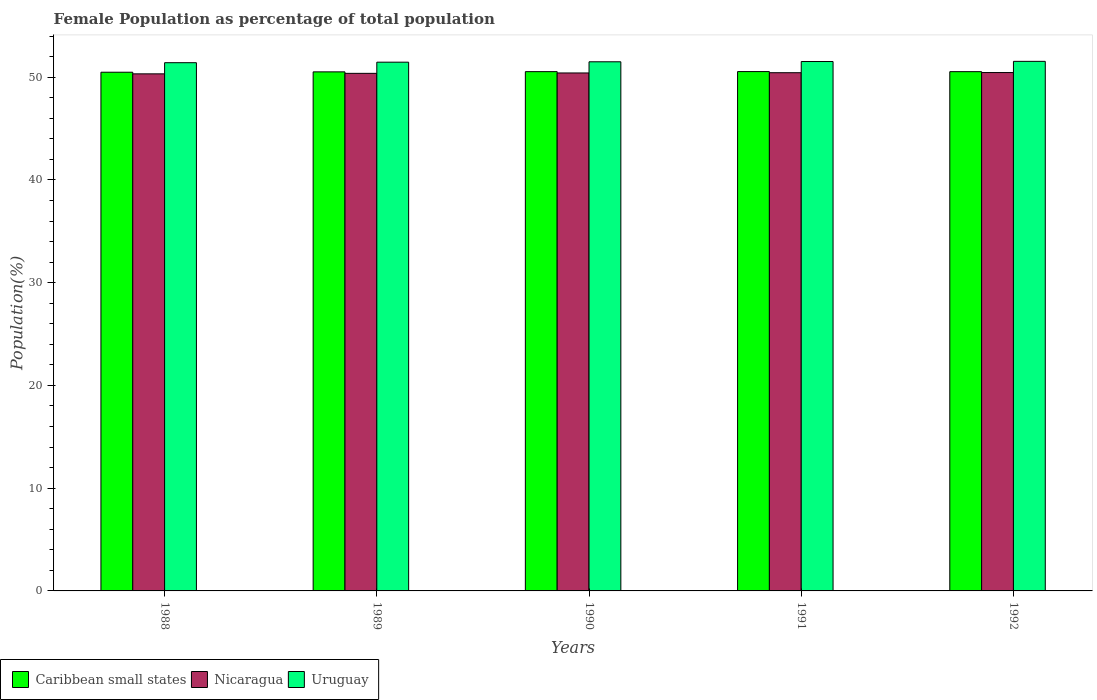How many groups of bars are there?
Your answer should be very brief. 5. Are the number of bars per tick equal to the number of legend labels?
Give a very brief answer. Yes. What is the label of the 1st group of bars from the left?
Your response must be concise. 1988. In how many cases, is the number of bars for a given year not equal to the number of legend labels?
Provide a succinct answer. 0. What is the female population in in Uruguay in 1992?
Give a very brief answer. 51.54. Across all years, what is the maximum female population in in Caribbean small states?
Offer a very short reply. 50.54. Across all years, what is the minimum female population in in Uruguay?
Offer a terse response. 51.41. In which year was the female population in in Caribbean small states minimum?
Your answer should be compact. 1988. What is the total female population in in Uruguay in the graph?
Offer a very short reply. 257.42. What is the difference between the female population in in Nicaragua in 1989 and that in 1992?
Provide a succinct answer. -0.08. What is the difference between the female population in in Nicaragua in 1992 and the female population in in Uruguay in 1988?
Your answer should be compact. -0.96. What is the average female population in in Caribbean small states per year?
Your response must be concise. 50.52. In the year 1989, what is the difference between the female population in in Caribbean small states and female population in in Uruguay?
Your answer should be very brief. -0.94. What is the ratio of the female population in in Uruguay in 1991 to that in 1992?
Keep it short and to the point. 1. Is the difference between the female population in in Caribbean small states in 1990 and 1991 greater than the difference between the female population in in Uruguay in 1990 and 1991?
Provide a succinct answer. Yes. What is the difference between the highest and the second highest female population in in Uruguay?
Offer a terse response. 0.02. What is the difference between the highest and the lowest female population in in Nicaragua?
Make the answer very short. 0.13. In how many years, is the female population in in Caribbean small states greater than the average female population in in Caribbean small states taken over all years?
Offer a terse response. 3. Is the sum of the female population in in Uruguay in 1988 and 1990 greater than the maximum female population in in Nicaragua across all years?
Offer a terse response. Yes. What does the 3rd bar from the left in 1988 represents?
Offer a terse response. Uruguay. What does the 3rd bar from the right in 1988 represents?
Provide a succinct answer. Caribbean small states. Are all the bars in the graph horizontal?
Keep it short and to the point. No. How many years are there in the graph?
Make the answer very short. 5. What is the difference between two consecutive major ticks on the Y-axis?
Provide a succinct answer. 10. Are the values on the major ticks of Y-axis written in scientific E-notation?
Your answer should be compact. No. Does the graph contain any zero values?
Your answer should be very brief. No. Where does the legend appear in the graph?
Your answer should be very brief. Bottom left. How are the legend labels stacked?
Provide a short and direct response. Horizontal. What is the title of the graph?
Ensure brevity in your answer.  Female Population as percentage of total population. Does "South Asia" appear as one of the legend labels in the graph?
Your answer should be very brief. No. What is the label or title of the X-axis?
Offer a terse response. Years. What is the label or title of the Y-axis?
Make the answer very short. Population(%). What is the Population(%) of Caribbean small states in 1988?
Give a very brief answer. 50.48. What is the Population(%) of Nicaragua in 1988?
Your answer should be compact. 50.32. What is the Population(%) in Uruguay in 1988?
Provide a succinct answer. 51.41. What is the Population(%) in Caribbean small states in 1989?
Your response must be concise. 50.51. What is the Population(%) of Nicaragua in 1989?
Provide a short and direct response. 50.37. What is the Population(%) in Uruguay in 1989?
Provide a short and direct response. 51.46. What is the Population(%) in Caribbean small states in 1990?
Provide a short and direct response. 50.54. What is the Population(%) in Nicaragua in 1990?
Provide a short and direct response. 50.41. What is the Population(%) in Uruguay in 1990?
Provide a short and direct response. 51.5. What is the Population(%) of Caribbean small states in 1991?
Provide a succinct answer. 50.54. What is the Population(%) in Nicaragua in 1991?
Make the answer very short. 50.43. What is the Population(%) of Uruguay in 1991?
Make the answer very short. 51.52. What is the Population(%) of Caribbean small states in 1992?
Provide a succinct answer. 50.53. What is the Population(%) in Nicaragua in 1992?
Make the answer very short. 50.45. What is the Population(%) in Uruguay in 1992?
Your response must be concise. 51.54. Across all years, what is the maximum Population(%) in Caribbean small states?
Offer a very short reply. 50.54. Across all years, what is the maximum Population(%) of Nicaragua?
Ensure brevity in your answer.  50.45. Across all years, what is the maximum Population(%) in Uruguay?
Make the answer very short. 51.54. Across all years, what is the minimum Population(%) in Caribbean small states?
Offer a very short reply. 50.48. Across all years, what is the minimum Population(%) of Nicaragua?
Your answer should be very brief. 50.32. Across all years, what is the minimum Population(%) of Uruguay?
Offer a terse response. 51.41. What is the total Population(%) in Caribbean small states in the graph?
Offer a terse response. 252.6. What is the total Population(%) of Nicaragua in the graph?
Provide a short and direct response. 251.98. What is the total Population(%) of Uruguay in the graph?
Ensure brevity in your answer.  257.42. What is the difference between the Population(%) in Caribbean small states in 1988 and that in 1989?
Give a very brief answer. -0.04. What is the difference between the Population(%) of Nicaragua in 1988 and that in 1989?
Your answer should be compact. -0.05. What is the difference between the Population(%) of Uruguay in 1988 and that in 1989?
Make the answer very short. -0.05. What is the difference between the Population(%) of Caribbean small states in 1988 and that in 1990?
Provide a succinct answer. -0.06. What is the difference between the Population(%) of Nicaragua in 1988 and that in 1990?
Make the answer very short. -0.09. What is the difference between the Population(%) in Uruguay in 1988 and that in 1990?
Your answer should be compact. -0.09. What is the difference between the Population(%) in Caribbean small states in 1988 and that in 1991?
Keep it short and to the point. -0.06. What is the difference between the Population(%) in Nicaragua in 1988 and that in 1991?
Ensure brevity in your answer.  -0.11. What is the difference between the Population(%) of Uruguay in 1988 and that in 1991?
Offer a terse response. -0.11. What is the difference between the Population(%) of Caribbean small states in 1988 and that in 1992?
Give a very brief answer. -0.05. What is the difference between the Population(%) of Nicaragua in 1988 and that in 1992?
Make the answer very short. -0.13. What is the difference between the Population(%) of Uruguay in 1988 and that in 1992?
Keep it short and to the point. -0.13. What is the difference between the Population(%) in Caribbean small states in 1989 and that in 1990?
Offer a very short reply. -0.02. What is the difference between the Population(%) in Nicaragua in 1989 and that in 1990?
Offer a terse response. -0.04. What is the difference between the Population(%) in Uruguay in 1989 and that in 1990?
Your answer should be compact. -0.04. What is the difference between the Population(%) of Caribbean small states in 1989 and that in 1991?
Make the answer very short. -0.03. What is the difference between the Population(%) of Nicaragua in 1989 and that in 1991?
Make the answer very short. -0.06. What is the difference between the Population(%) in Uruguay in 1989 and that in 1991?
Provide a short and direct response. -0.06. What is the difference between the Population(%) in Caribbean small states in 1989 and that in 1992?
Your response must be concise. -0.02. What is the difference between the Population(%) of Nicaragua in 1989 and that in 1992?
Provide a succinct answer. -0.08. What is the difference between the Population(%) in Uruguay in 1989 and that in 1992?
Your answer should be very brief. -0.08. What is the difference between the Population(%) in Caribbean small states in 1990 and that in 1991?
Provide a succinct answer. -0.01. What is the difference between the Population(%) of Nicaragua in 1990 and that in 1991?
Offer a very short reply. -0.03. What is the difference between the Population(%) of Uruguay in 1990 and that in 1991?
Make the answer very short. -0.03. What is the difference between the Population(%) of Caribbean small states in 1990 and that in 1992?
Your response must be concise. 0. What is the difference between the Population(%) in Nicaragua in 1990 and that in 1992?
Keep it short and to the point. -0.04. What is the difference between the Population(%) of Uruguay in 1990 and that in 1992?
Your response must be concise. -0.04. What is the difference between the Population(%) in Caribbean small states in 1991 and that in 1992?
Your response must be concise. 0.01. What is the difference between the Population(%) in Nicaragua in 1991 and that in 1992?
Your answer should be compact. -0.01. What is the difference between the Population(%) in Uruguay in 1991 and that in 1992?
Make the answer very short. -0.02. What is the difference between the Population(%) in Caribbean small states in 1988 and the Population(%) in Nicaragua in 1989?
Make the answer very short. 0.11. What is the difference between the Population(%) in Caribbean small states in 1988 and the Population(%) in Uruguay in 1989?
Provide a succinct answer. -0.98. What is the difference between the Population(%) of Nicaragua in 1988 and the Population(%) of Uruguay in 1989?
Ensure brevity in your answer.  -1.13. What is the difference between the Population(%) in Caribbean small states in 1988 and the Population(%) in Nicaragua in 1990?
Ensure brevity in your answer.  0.07. What is the difference between the Population(%) of Caribbean small states in 1988 and the Population(%) of Uruguay in 1990?
Offer a very short reply. -1.02. What is the difference between the Population(%) of Nicaragua in 1988 and the Population(%) of Uruguay in 1990?
Provide a short and direct response. -1.17. What is the difference between the Population(%) in Caribbean small states in 1988 and the Population(%) in Nicaragua in 1991?
Ensure brevity in your answer.  0.05. What is the difference between the Population(%) of Caribbean small states in 1988 and the Population(%) of Uruguay in 1991?
Your answer should be very brief. -1.04. What is the difference between the Population(%) of Nicaragua in 1988 and the Population(%) of Uruguay in 1991?
Your answer should be compact. -1.2. What is the difference between the Population(%) in Caribbean small states in 1988 and the Population(%) in Nicaragua in 1992?
Ensure brevity in your answer.  0.03. What is the difference between the Population(%) of Caribbean small states in 1988 and the Population(%) of Uruguay in 1992?
Keep it short and to the point. -1.06. What is the difference between the Population(%) of Nicaragua in 1988 and the Population(%) of Uruguay in 1992?
Your answer should be compact. -1.22. What is the difference between the Population(%) in Caribbean small states in 1989 and the Population(%) in Nicaragua in 1990?
Your answer should be very brief. 0.11. What is the difference between the Population(%) in Caribbean small states in 1989 and the Population(%) in Uruguay in 1990?
Your response must be concise. -0.98. What is the difference between the Population(%) in Nicaragua in 1989 and the Population(%) in Uruguay in 1990?
Offer a terse response. -1.12. What is the difference between the Population(%) in Caribbean small states in 1989 and the Population(%) in Nicaragua in 1991?
Give a very brief answer. 0.08. What is the difference between the Population(%) in Caribbean small states in 1989 and the Population(%) in Uruguay in 1991?
Your answer should be very brief. -1.01. What is the difference between the Population(%) of Nicaragua in 1989 and the Population(%) of Uruguay in 1991?
Provide a short and direct response. -1.15. What is the difference between the Population(%) in Caribbean small states in 1989 and the Population(%) in Nicaragua in 1992?
Ensure brevity in your answer.  0.07. What is the difference between the Population(%) of Caribbean small states in 1989 and the Population(%) of Uruguay in 1992?
Make the answer very short. -1.02. What is the difference between the Population(%) in Nicaragua in 1989 and the Population(%) in Uruguay in 1992?
Your response must be concise. -1.17. What is the difference between the Population(%) of Caribbean small states in 1990 and the Population(%) of Nicaragua in 1991?
Make the answer very short. 0.1. What is the difference between the Population(%) in Caribbean small states in 1990 and the Population(%) in Uruguay in 1991?
Your answer should be compact. -0.99. What is the difference between the Population(%) of Nicaragua in 1990 and the Population(%) of Uruguay in 1991?
Offer a very short reply. -1.11. What is the difference between the Population(%) of Caribbean small states in 1990 and the Population(%) of Nicaragua in 1992?
Your response must be concise. 0.09. What is the difference between the Population(%) in Caribbean small states in 1990 and the Population(%) in Uruguay in 1992?
Your answer should be very brief. -1. What is the difference between the Population(%) in Nicaragua in 1990 and the Population(%) in Uruguay in 1992?
Provide a succinct answer. -1.13. What is the difference between the Population(%) in Caribbean small states in 1991 and the Population(%) in Nicaragua in 1992?
Your answer should be compact. 0.09. What is the difference between the Population(%) of Caribbean small states in 1991 and the Population(%) of Uruguay in 1992?
Give a very brief answer. -1. What is the difference between the Population(%) in Nicaragua in 1991 and the Population(%) in Uruguay in 1992?
Make the answer very short. -1.1. What is the average Population(%) of Caribbean small states per year?
Make the answer very short. 50.52. What is the average Population(%) of Nicaragua per year?
Provide a short and direct response. 50.4. What is the average Population(%) of Uruguay per year?
Your answer should be compact. 51.48. In the year 1988, what is the difference between the Population(%) of Caribbean small states and Population(%) of Nicaragua?
Offer a very short reply. 0.16. In the year 1988, what is the difference between the Population(%) of Caribbean small states and Population(%) of Uruguay?
Offer a terse response. -0.93. In the year 1988, what is the difference between the Population(%) of Nicaragua and Population(%) of Uruguay?
Offer a terse response. -1.08. In the year 1989, what is the difference between the Population(%) in Caribbean small states and Population(%) in Nicaragua?
Your response must be concise. 0.14. In the year 1989, what is the difference between the Population(%) in Caribbean small states and Population(%) in Uruguay?
Your answer should be very brief. -0.94. In the year 1989, what is the difference between the Population(%) in Nicaragua and Population(%) in Uruguay?
Offer a terse response. -1.09. In the year 1990, what is the difference between the Population(%) of Caribbean small states and Population(%) of Nicaragua?
Make the answer very short. 0.13. In the year 1990, what is the difference between the Population(%) in Caribbean small states and Population(%) in Uruguay?
Provide a short and direct response. -0.96. In the year 1990, what is the difference between the Population(%) in Nicaragua and Population(%) in Uruguay?
Your answer should be compact. -1.09. In the year 1991, what is the difference between the Population(%) in Caribbean small states and Population(%) in Nicaragua?
Offer a very short reply. 0.11. In the year 1991, what is the difference between the Population(%) in Caribbean small states and Population(%) in Uruguay?
Keep it short and to the point. -0.98. In the year 1991, what is the difference between the Population(%) of Nicaragua and Population(%) of Uruguay?
Your answer should be very brief. -1.09. In the year 1992, what is the difference between the Population(%) of Caribbean small states and Population(%) of Nicaragua?
Your response must be concise. 0.09. In the year 1992, what is the difference between the Population(%) in Caribbean small states and Population(%) in Uruguay?
Ensure brevity in your answer.  -1. In the year 1992, what is the difference between the Population(%) of Nicaragua and Population(%) of Uruguay?
Your answer should be compact. -1.09. What is the ratio of the Population(%) of Caribbean small states in 1988 to that in 1989?
Keep it short and to the point. 1. What is the ratio of the Population(%) in Uruguay in 1988 to that in 1989?
Provide a short and direct response. 1. What is the ratio of the Population(%) of Caribbean small states in 1988 to that in 1990?
Provide a succinct answer. 1. What is the ratio of the Population(%) of Nicaragua in 1988 to that in 1990?
Your response must be concise. 1. What is the ratio of the Population(%) of Uruguay in 1988 to that in 1990?
Provide a short and direct response. 1. What is the ratio of the Population(%) of Caribbean small states in 1988 to that in 1991?
Offer a very short reply. 1. What is the ratio of the Population(%) in Caribbean small states in 1988 to that in 1992?
Provide a succinct answer. 1. What is the ratio of the Population(%) of Uruguay in 1989 to that in 1990?
Make the answer very short. 1. What is the ratio of the Population(%) in Nicaragua in 1989 to that in 1991?
Offer a terse response. 1. What is the ratio of the Population(%) in Uruguay in 1989 to that in 1991?
Keep it short and to the point. 1. What is the ratio of the Population(%) in Nicaragua in 1990 to that in 1991?
Make the answer very short. 1. What is the ratio of the Population(%) of Caribbean small states in 1991 to that in 1992?
Your answer should be very brief. 1. What is the difference between the highest and the second highest Population(%) in Caribbean small states?
Offer a terse response. 0.01. What is the difference between the highest and the second highest Population(%) of Nicaragua?
Your response must be concise. 0.01. What is the difference between the highest and the second highest Population(%) in Uruguay?
Ensure brevity in your answer.  0.02. What is the difference between the highest and the lowest Population(%) of Caribbean small states?
Your answer should be compact. 0.06. What is the difference between the highest and the lowest Population(%) of Nicaragua?
Give a very brief answer. 0.13. What is the difference between the highest and the lowest Population(%) in Uruguay?
Offer a very short reply. 0.13. 